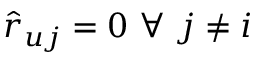<formula> <loc_0><loc_0><loc_500><loc_500>\hat { r } _ { u j } = 0 \ \forall \ j \neq i</formula> 